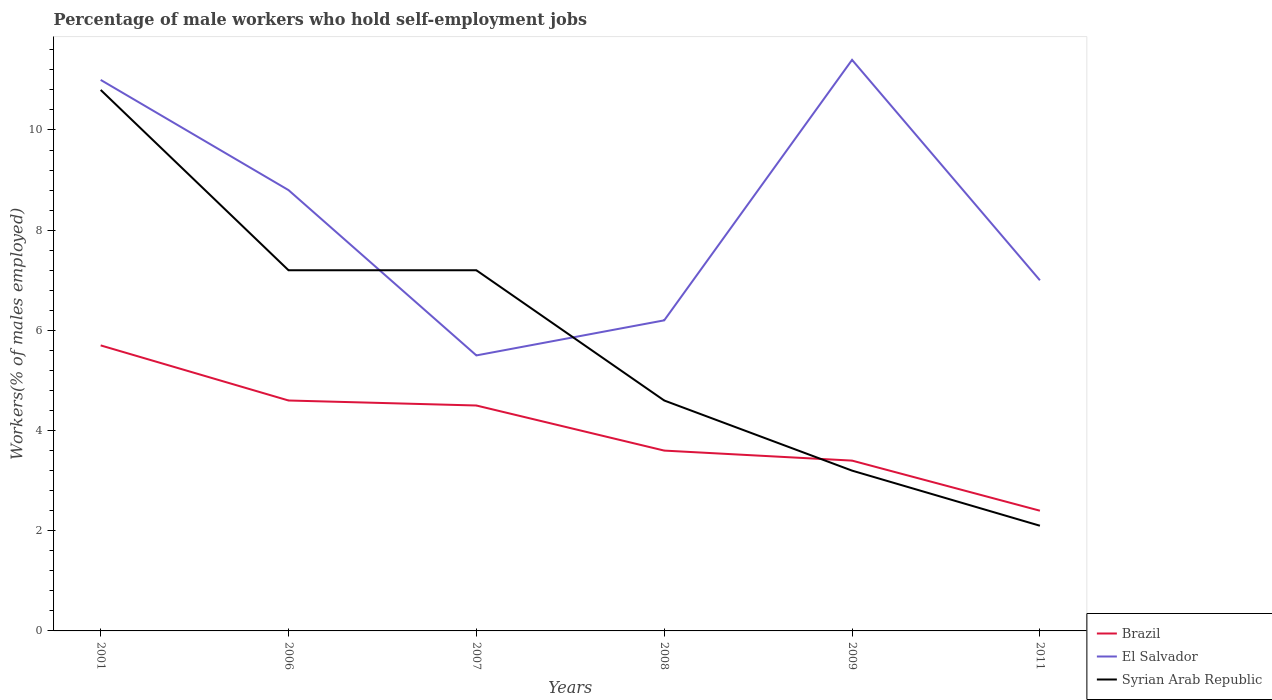Does the line corresponding to Syrian Arab Republic intersect with the line corresponding to El Salvador?
Your response must be concise. Yes. Is the number of lines equal to the number of legend labels?
Your answer should be very brief. Yes. Across all years, what is the maximum percentage of self-employed male workers in Brazil?
Provide a short and direct response. 2.4. In which year was the percentage of self-employed male workers in Brazil maximum?
Your answer should be very brief. 2011. What is the total percentage of self-employed male workers in Syrian Arab Republic in the graph?
Your answer should be compact. 1.1. What is the difference between the highest and the second highest percentage of self-employed male workers in Syrian Arab Republic?
Your answer should be compact. 8.7. What is the difference between the highest and the lowest percentage of self-employed male workers in El Salvador?
Your answer should be very brief. 3. How many lines are there?
Offer a terse response. 3. What is the difference between two consecutive major ticks on the Y-axis?
Give a very brief answer. 2. Does the graph contain any zero values?
Give a very brief answer. No. Does the graph contain grids?
Ensure brevity in your answer.  No. How many legend labels are there?
Offer a terse response. 3. What is the title of the graph?
Your response must be concise. Percentage of male workers who hold self-employment jobs. Does "Equatorial Guinea" appear as one of the legend labels in the graph?
Make the answer very short. No. What is the label or title of the X-axis?
Offer a very short reply. Years. What is the label or title of the Y-axis?
Make the answer very short. Workers(% of males employed). What is the Workers(% of males employed) in Brazil in 2001?
Your response must be concise. 5.7. What is the Workers(% of males employed) in Syrian Arab Republic in 2001?
Provide a short and direct response. 10.8. What is the Workers(% of males employed) of Brazil in 2006?
Provide a short and direct response. 4.6. What is the Workers(% of males employed) of El Salvador in 2006?
Your response must be concise. 8.8. What is the Workers(% of males employed) of Syrian Arab Republic in 2006?
Ensure brevity in your answer.  7.2. What is the Workers(% of males employed) in El Salvador in 2007?
Your answer should be compact. 5.5. What is the Workers(% of males employed) of Syrian Arab Republic in 2007?
Your answer should be compact. 7.2. What is the Workers(% of males employed) of Brazil in 2008?
Your answer should be compact. 3.6. What is the Workers(% of males employed) in El Salvador in 2008?
Provide a short and direct response. 6.2. What is the Workers(% of males employed) of Syrian Arab Republic in 2008?
Provide a short and direct response. 4.6. What is the Workers(% of males employed) of Brazil in 2009?
Your answer should be compact. 3.4. What is the Workers(% of males employed) in El Salvador in 2009?
Your answer should be very brief. 11.4. What is the Workers(% of males employed) in Syrian Arab Republic in 2009?
Your answer should be very brief. 3.2. What is the Workers(% of males employed) of Brazil in 2011?
Make the answer very short. 2.4. What is the Workers(% of males employed) of Syrian Arab Republic in 2011?
Your answer should be compact. 2.1. Across all years, what is the maximum Workers(% of males employed) in Brazil?
Your answer should be compact. 5.7. Across all years, what is the maximum Workers(% of males employed) in El Salvador?
Offer a very short reply. 11.4. Across all years, what is the maximum Workers(% of males employed) in Syrian Arab Republic?
Your response must be concise. 10.8. Across all years, what is the minimum Workers(% of males employed) of Brazil?
Your answer should be compact. 2.4. Across all years, what is the minimum Workers(% of males employed) of Syrian Arab Republic?
Offer a terse response. 2.1. What is the total Workers(% of males employed) in Brazil in the graph?
Keep it short and to the point. 24.2. What is the total Workers(% of males employed) in El Salvador in the graph?
Offer a terse response. 49.9. What is the total Workers(% of males employed) of Syrian Arab Republic in the graph?
Provide a short and direct response. 35.1. What is the difference between the Workers(% of males employed) in Brazil in 2001 and that in 2006?
Provide a short and direct response. 1.1. What is the difference between the Workers(% of males employed) of El Salvador in 2001 and that in 2006?
Your answer should be very brief. 2.2. What is the difference between the Workers(% of males employed) of Syrian Arab Republic in 2001 and that in 2006?
Your answer should be very brief. 3.6. What is the difference between the Workers(% of males employed) of Brazil in 2001 and that in 2007?
Offer a very short reply. 1.2. What is the difference between the Workers(% of males employed) in Syrian Arab Republic in 2001 and that in 2007?
Make the answer very short. 3.6. What is the difference between the Workers(% of males employed) of Brazil in 2001 and that in 2008?
Your answer should be very brief. 2.1. What is the difference between the Workers(% of males employed) in El Salvador in 2001 and that in 2008?
Keep it short and to the point. 4.8. What is the difference between the Workers(% of males employed) in Syrian Arab Republic in 2001 and that in 2008?
Your answer should be compact. 6.2. What is the difference between the Workers(% of males employed) of Brazil in 2001 and that in 2009?
Provide a succinct answer. 2.3. What is the difference between the Workers(% of males employed) of El Salvador in 2001 and that in 2009?
Your answer should be compact. -0.4. What is the difference between the Workers(% of males employed) in Syrian Arab Republic in 2001 and that in 2009?
Make the answer very short. 7.6. What is the difference between the Workers(% of males employed) in Brazil in 2001 and that in 2011?
Give a very brief answer. 3.3. What is the difference between the Workers(% of males employed) of El Salvador in 2001 and that in 2011?
Give a very brief answer. 4. What is the difference between the Workers(% of males employed) in Syrian Arab Republic in 2001 and that in 2011?
Your answer should be compact. 8.7. What is the difference between the Workers(% of males employed) of Syrian Arab Republic in 2006 and that in 2007?
Offer a terse response. 0. What is the difference between the Workers(% of males employed) of Brazil in 2006 and that in 2011?
Your answer should be very brief. 2.2. What is the difference between the Workers(% of males employed) in Syrian Arab Republic in 2006 and that in 2011?
Make the answer very short. 5.1. What is the difference between the Workers(% of males employed) of El Salvador in 2007 and that in 2008?
Keep it short and to the point. -0.7. What is the difference between the Workers(% of males employed) in Syrian Arab Republic in 2007 and that in 2009?
Keep it short and to the point. 4. What is the difference between the Workers(% of males employed) in El Salvador in 2007 and that in 2011?
Your answer should be compact. -1.5. What is the difference between the Workers(% of males employed) of El Salvador in 2008 and that in 2009?
Offer a very short reply. -5.2. What is the difference between the Workers(% of males employed) in Syrian Arab Republic in 2008 and that in 2009?
Provide a succinct answer. 1.4. What is the difference between the Workers(% of males employed) of Syrian Arab Republic in 2008 and that in 2011?
Your response must be concise. 2.5. What is the difference between the Workers(% of males employed) in Brazil in 2009 and that in 2011?
Your answer should be very brief. 1. What is the difference between the Workers(% of males employed) of Brazil in 2001 and the Workers(% of males employed) of El Salvador in 2006?
Keep it short and to the point. -3.1. What is the difference between the Workers(% of males employed) in Brazil in 2001 and the Workers(% of males employed) in El Salvador in 2008?
Offer a terse response. -0.5. What is the difference between the Workers(% of males employed) in Brazil in 2001 and the Workers(% of males employed) in Syrian Arab Republic in 2009?
Provide a short and direct response. 2.5. What is the difference between the Workers(% of males employed) of El Salvador in 2001 and the Workers(% of males employed) of Syrian Arab Republic in 2009?
Keep it short and to the point. 7.8. What is the difference between the Workers(% of males employed) of Brazil in 2001 and the Workers(% of males employed) of El Salvador in 2011?
Make the answer very short. -1.3. What is the difference between the Workers(% of males employed) of Brazil in 2001 and the Workers(% of males employed) of Syrian Arab Republic in 2011?
Offer a terse response. 3.6. What is the difference between the Workers(% of males employed) in El Salvador in 2001 and the Workers(% of males employed) in Syrian Arab Republic in 2011?
Offer a terse response. 8.9. What is the difference between the Workers(% of males employed) of Brazil in 2006 and the Workers(% of males employed) of Syrian Arab Republic in 2007?
Offer a terse response. -2.6. What is the difference between the Workers(% of males employed) of Brazil in 2006 and the Workers(% of males employed) of El Salvador in 2008?
Offer a very short reply. -1.6. What is the difference between the Workers(% of males employed) in Brazil in 2006 and the Workers(% of males employed) in Syrian Arab Republic in 2008?
Offer a very short reply. 0. What is the difference between the Workers(% of males employed) of Brazil in 2006 and the Workers(% of males employed) of El Salvador in 2009?
Your answer should be very brief. -6.8. What is the difference between the Workers(% of males employed) of Brazil in 2006 and the Workers(% of males employed) of El Salvador in 2011?
Ensure brevity in your answer.  -2.4. What is the difference between the Workers(% of males employed) of Brazil in 2006 and the Workers(% of males employed) of Syrian Arab Republic in 2011?
Provide a short and direct response. 2.5. What is the difference between the Workers(% of males employed) of Brazil in 2007 and the Workers(% of males employed) of Syrian Arab Republic in 2009?
Ensure brevity in your answer.  1.3. What is the difference between the Workers(% of males employed) of Brazil in 2007 and the Workers(% of males employed) of Syrian Arab Republic in 2011?
Your response must be concise. 2.4. What is the difference between the Workers(% of males employed) in El Salvador in 2008 and the Workers(% of males employed) in Syrian Arab Republic in 2011?
Ensure brevity in your answer.  4.1. What is the difference between the Workers(% of males employed) in Brazil in 2009 and the Workers(% of males employed) in El Salvador in 2011?
Give a very brief answer. -3.6. What is the difference between the Workers(% of males employed) in Brazil in 2009 and the Workers(% of males employed) in Syrian Arab Republic in 2011?
Keep it short and to the point. 1.3. What is the average Workers(% of males employed) in Brazil per year?
Make the answer very short. 4.03. What is the average Workers(% of males employed) of El Salvador per year?
Give a very brief answer. 8.32. What is the average Workers(% of males employed) in Syrian Arab Republic per year?
Provide a short and direct response. 5.85. In the year 2006, what is the difference between the Workers(% of males employed) in Brazil and Workers(% of males employed) in El Salvador?
Give a very brief answer. -4.2. In the year 2006, what is the difference between the Workers(% of males employed) of El Salvador and Workers(% of males employed) of Syrian Arab Republic?
Provide a short and direct response. 1.6. In the year 2007, what is the difference between the Workers(% of males employed) in Brazil and Workers(% of males employed) in Syrian Arab Republic?
Keep it short and to the point. -2.7. In the year 2009, what is the difference between the Workers(% of males employed) of Brazil and Workers(% of males employed) of Syrian Arab Republic?
Provide a succinct answer. 0.2. In the year 2011, what is the difference between the Workers(% of males employed) of Brazil and Workers(% of males employed) of El Salvador?
Make the answer very short. -4.6. In the year 2011, what is the difference between the Workers(% of males employed) of Brazil and Workers(% of males employed) of Syrian Arab Republic?
Give a very brief answer. 0.3. What is the ratio of the Workers(% of males employed) of Brazil in 2001 to that in 2006?
Your response must be concise. 1.24. What is the ratio of the Workers(% of males employed) of El Salvador in 2001 to that in 2006?
Your answer should be very brief. 1.25. What is the ratio of the Workers(% of males employed) of Syrian Arab Republic in 2001 to that in 2006?
Offer a very short reply. 1.5. What is the ratio of the Workers(% of males employed) in Brazil in 2001 to that in 2007?
Provide a short and direct response. 1.27. What is the ratio of the Workers(% of males employed) of Brazil in 2001 to that in 2008?
Offer a terse response. 1.58. What is the ratio of the Workers(% of males employed) in El Salvador in 2001 to that in 2008?
Make the answer very short. 1.77. What is the ratio of the Workers(% of males employed) of Syrian Arab Republic in 2001 to that in 2008?
Offer a very short reply. 2.35. What is the ratio of the Workers(% of males employed) of Brazil in 2001 to that in 2009?
Ensure brevity in your answer.  1.68. What is the ratio of the Workers(% of males employed) in El Salvador in 2001 to that in 2009?
Give a very brief answer. 0.96. What is the ratio of the Workers(% of males employed) in Syrian Arab Republic in 2001 to that in 2009?
Give a very brief answer. 3.38. What is the ratio of the Workers(% of males employed) of Brazil in 2001 to that in 2011?
Keep it short and to the point. 2.38. What is the ratio of the Workers(% of males employed) in El Salvador in 2001 to that in 2011?
Offer a very short reply. 1.57. What is the ratio of the Workers(% of males employed) of Syrian Arab Republic in 2001 to that in 2011?
Ensure brevity in your answer.  5.14. What is the ratio of the Workers(% of males employed) in Brazil in 2006 to that in 2007?
Provide a short and direct response. 1.02. What is the ratio of the Workers(% of males employed) in Brazil in 2006 to that in 2008?
Provide a short and direct response. 1.28. What is the ratio of the Workers(% of males employed) of El Salvador in 2006 to that in 2008?
Offer a very short reply. 1.42. What is the ratio of the Workers(% of males employed) in Syrian Arab Republic in 2006 to that in 2008?
Give a very brief answer. 1.57. What is the ratio of the Workers(% of males employed) in Brazil in 2006 to that in 2009?
Make the answer very short. 1.35. What is the ratio of the Workers(% of males employed) of El Salvador in 2006 to that in 2009?
Provide a short and direct response. 0.77. What is the ratio of the Workers(% of males employed) of Syrian Arab Republic in 2006 to that in 2009?
Your answer should be very brief. 2.25. What is the ratio of the Workers(% of males employed) of Brazil in 2006 to that in 2011?
Ensure brevity in your answer.  1.92. What is the ratio of the Workers(% of males employed) of El Salvador in 2006 to that in 2011?
Offer a very short reply. 1.26. What is the ratio of the Workers(% of males employed) in Syrian Arab Republic in 2006 to that in 2011?
Keep it short and to the point. 3.43. What is the ratio of the Workers(% of males employed) in Brazil in 2007 to that in 2008?
Give a very brief answer. 1.25. What is the ratio of the Workers(% of males employed) in El Salvador in 2007 to that in 2008?
Make the answer very short. 0.89. What is the ratio of the Workers(% of males employed) of Syrian Arab Republic in 2007 to that in 2008?
Ensure brevity in your answer.  1.57. What is the ratio of the Workers(% of males employed) of Brazil in 2007 to that in 2009?
Your answer should be compact. 1.32. What is the ratio of the Workers(% of males employed) in El Salvador in 2007 to that in 2009?
Give a very brief answer. 0.48. What is the ratio of the Workers(% of males employed) in Syrian Arab Republic in 2007 to that in 2009?
Offer a very short reply. 2.25. What is the ratio of the Workers(% of males employed) of Brazil in 2007 to that in 2011?
Your answer should be compact. 1.88. What is the ratio of the Workers(% of males employed) in El Salvador in 2007 to that in 2011?
Make the answer very short. 0.79. What is the ratio of the Workers(% of males employed) in Syrian Arab Republic in 2007 to that in 2011?
Your answer should be compact. 3.43. What is the ratio of the Workers(% of males employed) in Brazil in 2008 to that in 2009?
Provide a short and direct response. 1.06. What is the ratio of the Workers(% of males employed) of El Salvador in 2008 to that in 2009?
Your answer should be very brief. 0.54. What is the ratio of the Workers(% of males employed) in Syrian Arab Republic in 2008 to that in 2009?
Offer a terse response. 1.44. What is the ratio of the Workers(% of males employed) in Brazil in 2008 to that in 2011?
Give a very brief answer. 1.5. What is the ratio of the Workers(% of males employed) in El Salvador in 2008 to that in 2011?
Keep it short and to the point. 0.89. What is the ratio of the Workers(% of males employed) in Syrian Arab Republic in 2008 to that in 2011?
Your answer should be compact. 2.19. What is the ratio of the Workers(% of males employed) of Brazil in 2009 to that in 2011?
Offer a terse response. 1.42. What is the ratio of the Workers(% of males employed) in El Salvador in 2009 to that in 2011?
Give a very brief answer. 1.63. What is the ratio of the Workers(% of males employed) of Syrian Arab Republic in 2009 to that in 2011?
Keep it short and to the point. 1.52. What is the difference between the highest and the second highest Workers(% of males employed) of Brazil?
Provide a succinct answer. 1.1. What is the difference between the highest and the second highest Workers(% of males employed) of El Salvador?
Ensure brevity in your answer.  0.4. What is the difference between the highest and the second highest Workers(% of males employed) of Syrian Arab Republic?
Provide a short and direct response. 3.6. What is the difference between the highest and the lowest Workers(% of males employed) of El Salvador?
Keep it short and to the point. 5.9. What is the difference between the highest and the lowest Workers(% of males employed) of Syrian Arab Republic?
Make the answer very short. 8.7. 